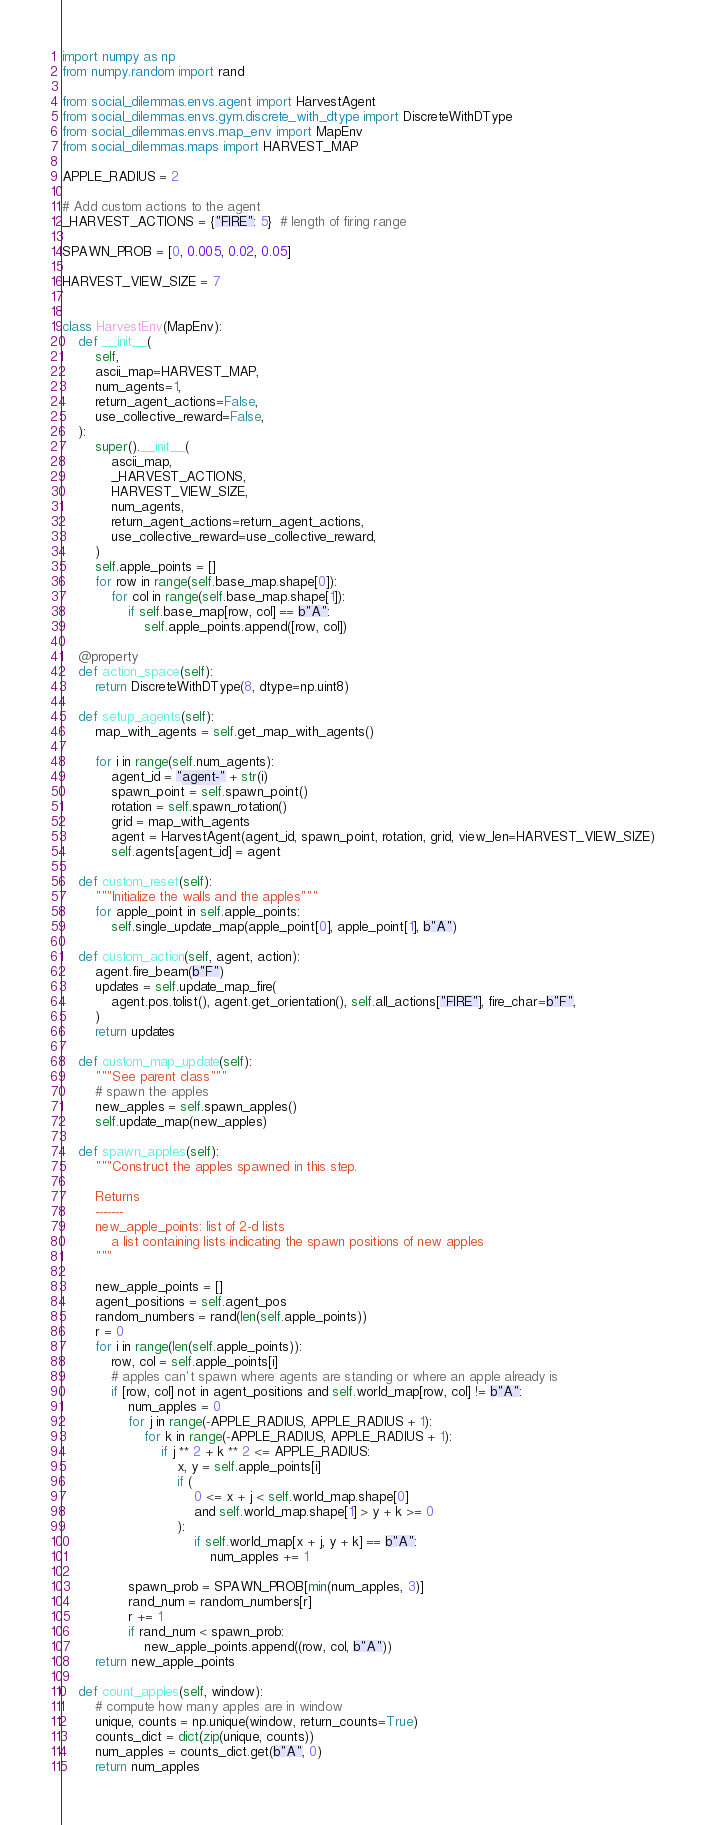Convert code to text. <code><loc_0><loc_0><loc_500><loc_500><_Python_>import numpy as np
from numpy.random import rand

from social_dilemmas.envs.agent import HarvestAgent
from social_dilemmas.envs.gym.discrete_with_dtype import DiscreteWithDType
from social_dilemmas.envs.map_env import MapEnv
from social_dilemmas.maps import HARVEST_MAP

APPLE_RADIUS = 2

# Add custom actions to the agent
_HARVEST_ACTIONS = {"FIRE": 5}  # length of firing range

SPAWN_PROB = [0, 0.005, 0.02, 0.05]

HARVEST_VIEW_SIZE = 7


class HarvestEnv(MapEnv):
    def __init__(
        self,
        ascii_map=HARVEST_MAP,
        num_agents=1,
        return_agent_actions=False,
        use_collective_reward=False,
    ):
        super().__init__(
            ascii_map,
            _HARVEST_ACTIONS,
            HARVEST_VIEW_SIZE,
            num_agents,
            return_agent_actions=return_agent_actions,
            use_collective_reward=use_collective_reward,
        )
        self.apple_points = []
        for row in range(self.base_map.shape[0]):
            for col in range(self.base_map.shape[1]):
                if self.base_map[row, col] == b"A":
                    self.apple_points.append([row, col])

    @property
    def action_space(self):
        return DiscreteWithDType(8, dtype=np.uint8)

    def setup_agents(self):
        map_with_agents = self.get_map_with_agents()

        for i in range(self.num_agents):
            agent_id = "agent-" + str(i)
            spawn_point = self.spawn_point()
            rotation = self.spawn_rotation()
            grid = map_with_agents
            agent = HarvestAgent(agent_id, spawn_point, rotation, grid, view_len=HARVEST_VIEW_SIZE)
            self.agents[agent_id] = agent

    def custom_reset(self):
        """Initialize the walls and the apples"""
        for apple_point in self.apple_points:
            self.single_update_map(apple_point[0], apple_point[1], b"A")

    def custom_action(self, agent, action):
        agent.fire_beam(b"F")
        updates = self.update_map_fire(
            agent.pos.tolist(), agent.get_orientation(), self.all_actions["FIRE"], fire_char=b"F",
        )
        return updates

    def custom_map_update(self):
        """See parent class"""
        # spawn the apples
        new_apples = self.spawn_apples()
        self.update_map(new_apples)

    def spawn_apples(self):
        """Construct the apples spawned in this step.

        Returns
        -------
        new_apple_points: list of 2-d lists
            a list containing lists indicating the spawn positions of new apples
        """

        new_apple_points = []
        agent_positions = self.agent_pos
        random_numbers = rand(len(self.apple_points))
        r = 0
        for i in range(len(self.apple_points)):
            row, col = self.apple_points[i]
            # apples can't spawn where agents are standing or where an apple already is
            if [row, col] not in agent_positions and self.world_map[row, col] != b"A":
                num_apples = 0
                for j in range(-APPLE_RADIUS, APPLE_RADIUS + 1):
                    for k in range(-APPLE_RADIUS, APPLE_RADIUS + 1):
                        if j ** 2 + k ** 2 <= APPLE_RADIUS:
                            x, y = self.apple_points[i]
                            if (
                                0 <= x + j < self.world_map.shape[0]
                                and self.world_map.shape[1] > y + k >= 0
                            ):
                                if self.world_map[x + j, y + k] == b"A":
                                    num_apples += 1

                spawn_prob = SPAWN_PROB[min(num_apples, 3)]
                rand_num = random_numbers[r]
                r += 1
                if rand_num < spawn_prob:
                    new_apple_points.append((row, col, b"A"))
        return new_apple_points

    def count_apples(self, window):
        # compute how many apples are in window
        unique, counts = np.unique(window, return_counts=True)
        counts_dict = dict(zip(unique, counts))
        num_apples = counts_dict.get(b"A", 0)
        return num_apples
</code> 